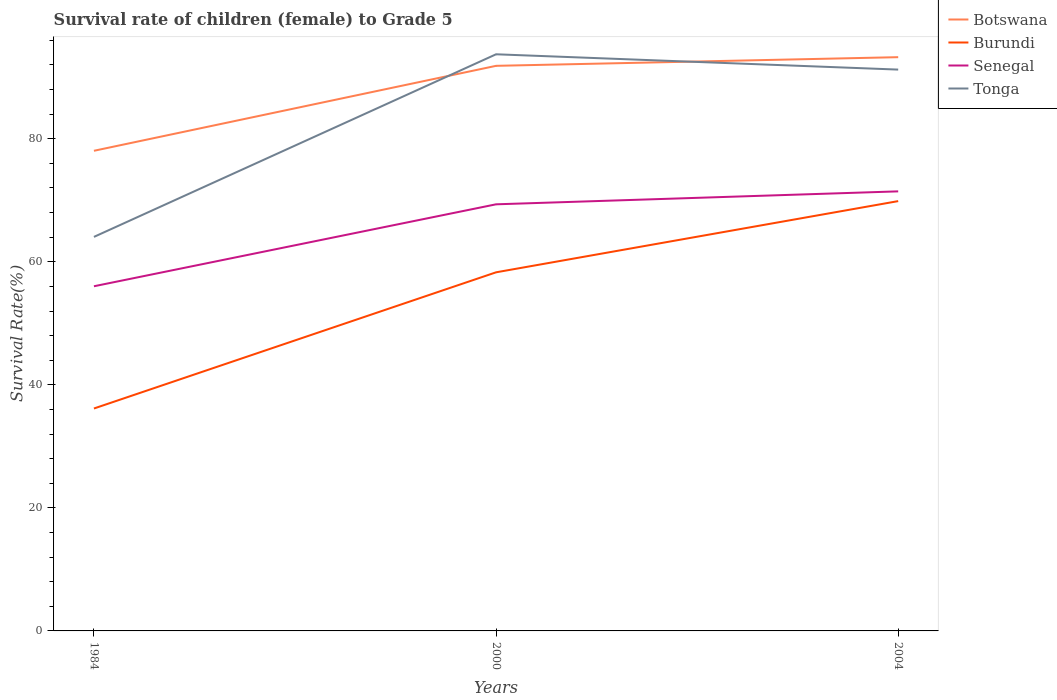Across all years, what is the maximum survival rate of female children to grade 5 in Burundi?
Your answer should be compact. 36.15. What is the total survival rate of female children to grade 5 in Senegal in the graph?
Make the answer very short. -15.42. What is the difference between the highest and the second highest survival rate of female children to grade 5 in Tonga?
Your answer should be very brief. 29.68. How many years are there in the graph?
Your response must be concise. 3. What is the difference between two consecutive major ticks on the Y-axis?
Give a very brief answer. 20. Does the graph contain any zero values?
Give a very brief answer. No. Does the graph contain grids?
Offer a terse response. No. What is the title of the graph?
Keep it short and to the point. Survival rate of children (female) to Grade 5. What is the label or title of the Y-axis?
Provide a succinct answer. Survival Rate(%). What is the Survival Rate(%) in Botswana in 1984?
Offer a very short reply. 78.04. What is the Survival Rate(%) of Burundi in 1984?
Keep it short and to the point. 36.15. What is the Survival Rate(%) of Senegal in 1984?
Your response must be concise. 56.02. What is the Survival Rate(%) in Tonga in 1984?
Ensure brevity in your answer.  64.05. What is the Survival Rate(%) of Botswana in 2000?
Give a very brief answer. 91.85. What is the Survival Rate(%) in Burundi in 2000?
Offer a terse response. 58.29. What is the Survival Rate(%) in Senegal in 2000?
Your answer should be very brief. 69.34. What is the Survival Rate(%) in Tonga in 2000?
Your response must be concise. 93.73. What is the Survival Rate(%) of Botswana in 2004?
Ensure brevity in your answer.  93.26. What is the Survival Rate(%) of Burundi in 2004?
Provide a succinct answer. 69.86. What is the Survival Rate(%) of Senegal in 2004?
Provide a succinct answer. 71.45. What is the Survival Rate(%) in Tonga in 2004?
Your answer should be compact. 91.24. Across all years, what is the maximum Survival Rate(%) of Botswana?
Keep it short and to the point. 93.26. Across all years, what is the maximum Survival Rate(%) in Burundi?
Your answer should be compact. 69.86. Across all years, what is the maximum Survival Rate(%) of Senegal?
Ensure brevity in your answer.  71.45. Across all years, what is the maximum Survival Rate(%) in Tonga?
Your answer should be compact. 93.73. Across all years, what is the minimum Survival Rate(%) of Botswana?
Your answer should be very brief. 78.04. Across all years, what is the minimum Survival Rate(%) of Burundi?
Provide a succinct answer. 36.15. Across all years, what is the minimum Survival Rate(%) in Senegal?
Your answer should be very brief. 56.02. Across all years, what is the minimum Survival Rate(%) in Tonga?
Make the answer very short. 64.05. What is the total Survival Rate(%) of Botswana in the graph?
Keep it short and to the point. 263.16. What is the total Survival Rate(%) of Burundi in the graph?
Your response must be concise. 164.31. What is the total Survival Rate(%) of Senegal in the graph?
Offer a very short reply. 196.82. What is the total Survival Rate(%) of Tonga in the graph?
Your response must be concise. 249.02. What is the difference between the Survival Rate(%) in Botswana in 1984 and that in 2000?
Your response must be concise. -13.81. What is the difference between the Survival Rate(%) of Burundi in 1984 and that in 2000?
Ensure brevity in your answer.  -22.14. What is the difference between the Survival Rate(%) in Senegal in 1984 and that in 2000?
Keep it short and to the point. -13.32. What is the difference between the Survival Rate(%) in Tonga in 1984 and that in 2000?
Your response must be concise. -29.68. What is the difference between the Survival Rate(%) in Botswana in 1984 and that in 2004?
Offer a terse response. -15.22. What is the difference between the Survival Rate(%) in Burundi in 1984 and that in 2004?
Your answer should be compact. -33.71. What is the difference between the Survival Rate(%) of Senegal in 1984 and that in 2004?
Provide a succinct answer. -15.42. What is the difference between the Survival Rate(%) of Tonga in 1984 and that in 2004?
Your answer should be compact. -27.19. What is the difference between the Survival Rate(%) of Botswana in 2000 and that in 2004?
Offer a terse response. -1.41. What is the difference between the Survival Rate(%) in Burundi in 2000 and that in 2004?
Your answer should be very brief. -11.57. What is the difference between the Survival Rate(%) of Senegal in 2000 and that in 2004?
Your response must be concise. -2.1. What is the difference between the Survival Rate(%) in Tonga in 2000 and that in 2004?
Ensure brevity in your answer.  2.49. What is the difference between the Survival Rate(%) in Botswana in 1984 and the Survival Rate(%) in Burundi in 2000?
Your answer should be very brief. 19.75. What is the difference between the Survival Rate(%) of Botswana in 1984 and the Survival Rate(%) of Senegal in 2000?
Ensure brevity in your answer.  8.7. What is the difference between the Survival Rate(%) of Botswana in 1984 and the Survival Rate(%) of Tonga in 2000?
Provide a succinct answer. -15.69. What is the difference between the Survival Rate(%) in Burundi in 1984 and the Survival Rate(%) in Senegal in 2000?
Ensure brevity in your answer.  -33.19. What is the difference between the Survival Rate(%) in Burundi in 1984 and the Survival Rate(%) in Tonga in 2000?
Offer a terse response. -57.58. What is the difference between the Survival Rate(%) in Senegal in 1984 and the Survival Rate(%) in Tonga in 2000?
Your answer should be compact. -37.71. What is the difference between the Survival Rate(%) in Botswana in 1984 and the Survival Rate(%) in Burundi in 2004?
Provide a short and direct response. 8.18. What is the difference between the Survival Rate(%) of Botswana in 1984 and the Survival Rate(%) of Senegal in 2004?
Offer a very short reply. 6.6. What is the difference between the Survival Rate(%) of Botswana in 1984 and the Survival Rate(%) of Tonga in 2004?
Provide a succinct answer. -13.2. What is the difference between the Survival Rate(%) in Burundi in 1984 and the Survival Rate(%) in Senegal in 2004?
Ensure brevity in your answer.  -35.29. What is the difference between the Survival Rate(%) in Burundi in 1984 and the Survival Rate(%) in Tonga in 2004?
Your answer should be compact. -55.09. What is the difference between the Survival Rate(%) of Senegal in 1984 and the Survival Rate(%) of Tonga in 2004?
Offer a very short reply. -35.22. What is the difference between the Survival Rate(%) of Botswana in 2000 and the Survival Rate(%) of Burundi in 2004?
Provide a succinct answer. 21.99. What is the difference between the Survival Rate(%) of Botswana in 2000 and the Survival Rate(%) of Senegal in 2004?
Offer a very short reply. 20.4. What is the difference between the Survival Rate(%) in Botswana in 2000 and the Survival Rate(%) in Tonga in 2004?
Keep it short and to the point. 0.61. What is the difference between the Survival Rate(%) in Burundi in 2000 and the Survival Rate(%) in Senegal in 2004?
Provide a short and direct response. -13.16. What is the difference between the Survival Rate(%) of Burundi in 2000 and the Survival Rate(%) of Tonga in 2004?
Make the answer very short. -32.95. What is the difference between the Survival Rate(%) of Senegal in 2000 and the Survival Rate(%) of Tonga in 2004?
Keep it short and to the point. -21.9. What is the average Survival Rate(%) in Botswana per year?
Keep it short and to the point. 87.72. What is the average Survival Rate(%) in Burundi per year?
Provide a succinct answer. 54.77. What is the average Survival Rate(%) in Senegal per year?
Your answer should be compact. 65.61. What is the average Survival Rate(%) of Tonga per year?
Ensure brevity in your answer.  83.01. In the year 1984, what is the difference between the Survival Rate(%) of Botswana and Survival Rate(%) of Burundi?
Provide a succinct answer. 41.89. In the year 1984, what is the difference between the Survival Rate(%) of Botswana and Survival Rate(%) of Senegal?
Your answer should be very brief. 22.02. In the year 1984, what is the difference between the Survival Rate(%) in Botswana and Survival Rate(%) in Tonga?
Ensure brevity in your answer.  14. In the year 1984, what is the difference between the Survival Rate(%) of Burundi and Survival Rate(%) of Senegal?
Give a very brief answer. -19.87. In the year 1984, what is the difference between the Survival Rate(%) of Burundi and Survival Rate(%) of Tonga?
Offer a terse response. -27.89. In the year 1984, what is the difference between the Survival Rate(%) of Senegal and Survival Rate(%) of Tonga?
Offer a terse response. -8.02. In the year 2000, what is the difference between the Survival Rate(%) in Botswana and Survival Rate(%) in Burundi?
Ensure brevity in your answer.  33.56. In the year 2000, what is the difference between the Survival Rate(%) in Botswana and Survival Rate(%) in Senegal?
Provide a short and direct response. 22.51. In the year 2000, what is the difference between the Survival Rate(%) in Botswana and Survival Rate(%) in Tonga?
Give a very brief answer. -1.88. In the year 2000, what is the difference between the Survival Rate(%) in Burundi and Survival Rate(%) in Senegal?
Your answer should be compact. -11.05. In the year 2000, what is the difference between the Survival Rate(%) of Burundi and Survival Rate(%) of Tonga?
Keep it short and to the point. -35.44. In the year 2000, what is the difference between the Survival Rate(%) in Senegal and Survival Rate(%) in Tonga?
Keep it short and to the point. -24.39. In the year 2004, what is the difference between the Survival Rate(%) of Botswana and Survival Rate(%) of Burundi?
Provide a short and direct response. 23.4. In the year 2004, what is the difference between the Survival Rate(%) of Botswana and Survival Rate(%) of Senegal?
Provide a short and direct response. 21.81. In the year 2004, what is the difference between the Survival Rate(%) of Botswana and Survival Rate(%) of Tonga?
Provide a succinct answer. 2.02. In the year 2004, what is the difference between the Survival Rate(%) of Burundi and Survival Rate(%) of Senegal?
Your response must be concise. -1.58. In the year 2004, what is the difference between the Survival Rate(%) in Burundi and Survival Rate(%) in Tonga?
Offer a very short reply. -21.38. In the year 2004, what is the difference between the Survival Rate(%) in Senegal and Survival Rate(%) in Tonga?
Your answer should be compact. -19.79. What is the ratio of the Survival Rate(%) of Botswana in 1984 to that in 2000?
Make the answer very short. 0.85. What is the ratio of the Survival Rate(%) of Burundi in 1984 to that in 2000?
Your answer should be compact. 0.62. What is the ratio of the Survival Rate(%) in Senegal in 1984 to that in 2000?
Make the answer very short. 0.81. What is the ratio of the Survival Rate(%) in Tonga in 1984 to that in 2000?
Provide a succinct answer. 0.68. What is the ratio of the Survival Rate(%) of Botswana in 1984 to that in 2004?
Provide a succinct answer. 0.84. What is the ratio of the Survival Rate(%) in Burundi in 1984 to that in 2004?
Offer a very short reply. 0.52. What is the ratio of the Survival Rate(%) in Senegal in 1984 to that in 2004?
Ensure brevity in your answer.  0.78. What is the ratio of the Survival Rate(%) of Tonga in 1984 to that in 2004?
Offer a very short reply. 0.7. What is the ratio of the Survival Rate(%) of Botswana in 2000 to that in 2004?
Give a very brief answer. 0.98. What is the ratio of the Survival Rate(%) in Burundi in 2000 to that in 2004?
Your answer should be very brief. 0.83. What is the ratio of the Survival Rate(%) in Senegal in 2000 to that in 2004?
Your answer should be compact. 0.97. What is the ratio of the Survival Rate(%) of Tonga in 2000 to that in 2004?
Your answer should be very brief. 1.03. What is the difference between the highest and the second highest Survival Rate(%) in Botswana?
Keep it short and to the point. 1.41. What is the difference between the highest and the second highest Survival Rate(%) of Burundi?
Give a very brief answer. 11.57. What is the difference between the highest and the second highest Survival Rate(%) of Senegal?
Offer a very short reply. 2.1. What is the difference between the highest and the second highest Survival Rate(%) of Tonga?
Give a very brief answer. 2.49. What is the difference between the highest and the lowest Survival Rate(%) of Botswana?
Your answer should be very brief. 15.22. What is the difference between the highest and the lowest Survival Rate(%) in Burundi?
Provide a short and direct response. 33.71. What is the difference between the highest and the lowest Survival Rate(%) of Senegal?
Your answer should be compact. 15.42. What is the difference between the highest and the lowest Survival Rate(%) of Tonga?
Keep it short and to the point. 29.68. 